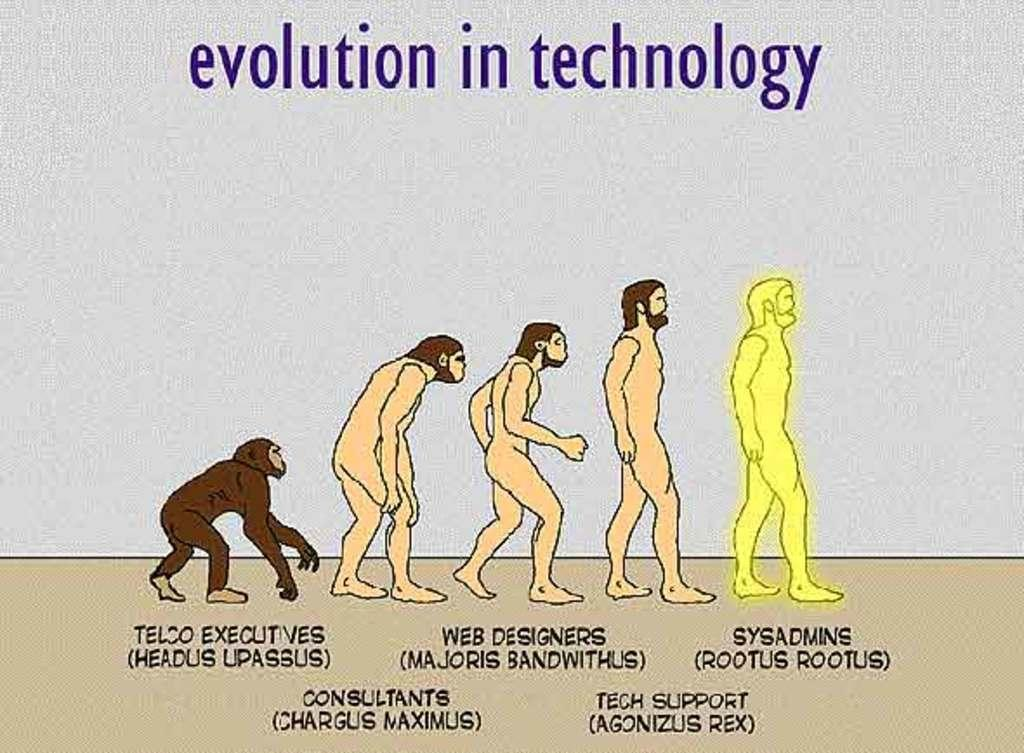What is the main subject of the image? The main subject of the image is a person. What additional information is provided about the person in the image? There is text related to the evolution of the person in the image. What type of reward can be seen in the image? There is no reward present in the image; it contains a depiction of a person and text related to their evolution. 